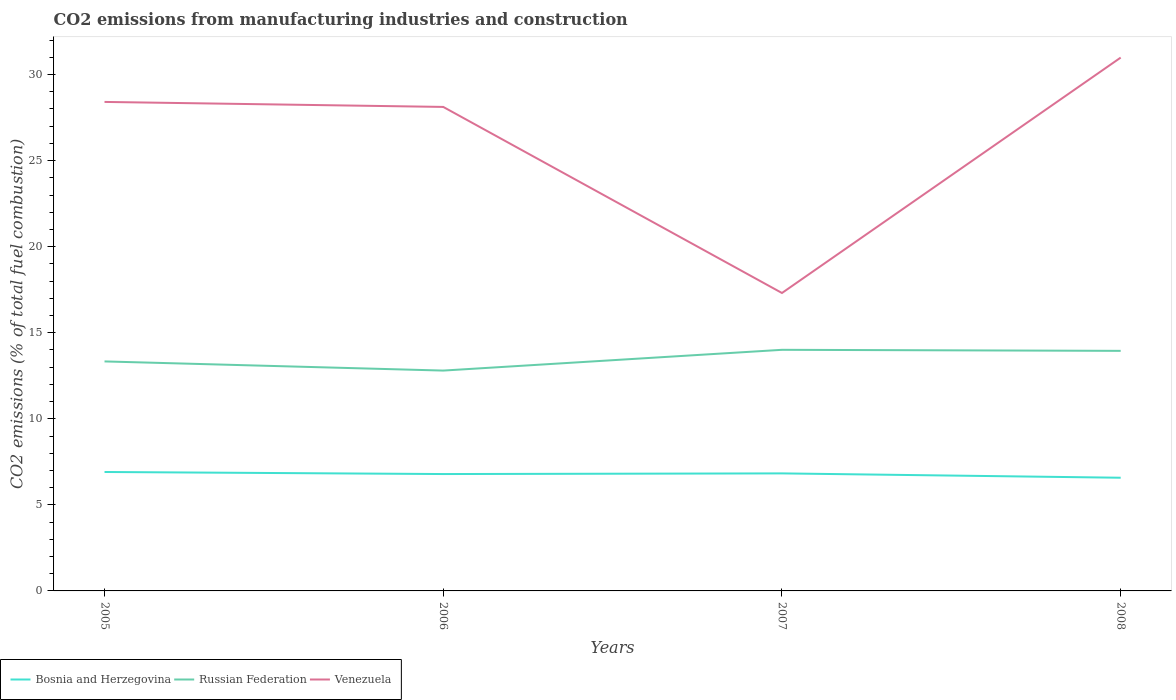How many different coloured lines are there?
Provide a short and direct response. 3. Does the line corresponding to Bosnia and Herzegovina intersect with the line corresponding to Russian Federation?
Offer a very short reply. No. Across all years, what is the maximum amount of CO2 emitted in Venezuela?
Ensure brevity in your answer.  17.31. In which year was the amount of CO2 emitted in Bosnia and Herzegovina maximum?
Offer a terse response. 2008. What is the total amount of CO2 emitted in Bosnia and Herzegovina in the graph?
Offer a very short reply. 0.33. What is the difference between the highest and the second highest amount of CO2 emitted in Venezuela?
Offer a very short reply. 13.68. Is the amount of CO2 emitted in Venezuela strictly greater than the amount of CO2 emitted in Bosnia and Herzegovina over the years?
Keep it short and to the point. No. How many lines are there?
Keep it short and to the point. 3. Does the graph contain any zero values?
Keep it short and to the point. No. How are the legend labels stacked?
Your response must be concise. Horizontal. What is the title of the graph?
Give a very brief answer. CO2 emissions from manufacturing industries and construction. Does "Liberia" appear as one of the legend labels in the graph?
Your answer should be compact. No. What is the label or title of the X-axis?
Ensure brevity in your answer.  Years. What is the label or title of the Y-axis?
Make the answer very short. CO2 emissions (% of total fuel combustion). What is the CO2 emissions (% of total fuel combustion) in Bosnia and Herzegovina in 2005?
Offer a very short reply. 6.91. What is the CO2 emissions (% of total fuel combustion) of Russian Federation in 2005?
Your response must be concise. 13.33. What is the CO2 emissions (% of total fuel combustion) of Venezuela in 2005?
Offer a terse response. 28.41. What is the CO2 emissions (% of total fuel combustion) in Bosnia and Herzegovina in 2006?
Make the answer very short. 6.79. What is the CO2 emissions (% of total fuel combustion) of Russian Federation in 2006?
Keep it short and to the point. 12.8. What is the CO2 emissions (% of total fuel combustion) of Venezuela in 2006?
Give a very brief answer. 28.12. What is the CO2 emissions (% of total fuel combustion) of Bosnia and Herzegovina in 2007?
Make the answer very short. 6.83. What is the CO2 emissions (% of total fuel combustion) in Russian Federation in 2007?
Keep it short and to the point. 14.01. What is the CO2 emissions (% of total fuel combustion) of Venezuela in 2007?
Your answer should be compact. 17.31. What is the CO2 emissions (% of total fuel combustion) of Bosnia and Herzegovina in 2008?
Keep it short and to the point. 6.58. What is the CO2 emissions (% of total fuel combustion) of Russian Federation in 2008?
Give a very brief answer. 13.95. What is the CO2 emissions (% of total fuel combustion) in Venezuela in 2008?
Provide a short and direct response. 30.99. Across all years, what is the maximum CO2 emissions (% of total fuel combustion) of Bosnia and Herzegovina?
Ensure brevity in your answer.  6.91. Across all years, what is the maximum CO2 emissions (% of total fuel combustion) in Russian Federation?
Ensure brevity in your answer.  14.01. Across all years, what is the maximum CO2 emissions (% of total fuel combustion) of Venezuela?
Make the answer very short. 30.99. Across all years, what is the minimum CO2 emissions (% of total fuel combustion) in Bosnia and Herzegovina?
Keep it short and to the point. 6.58. Across all years, what is the minimum CO2 emissions (% of total fuel combustion) of Russian Federation?
Keep it short and to the point. 12.8. Across all years, what is the minimum CO2 emissions (% of total fuel combustion) of Venezuela?
Offer a terse response. 17.31. What is the total CO2 emissions (% of total fuel combustion) in Bosnia and Herzegovina in the graph?
Give a very brief answer. 27.1. What is the total CO2 emissions (% of total fuel combustion) of Russian Federation in the graph?
Provide a succinct answer. 54.09. What is the total CO2 emissions (% of total fuel combustion) in Venezuela in the graph?
Offer a very short reply. 104.83. What is the difference between the CO2 emissions (% of total fuel combustion) of Bosnia and Herzegovina in 2005 and that in 2006?
Offer a very short reply. 0.12. What is the difference between the CO2 emissions (% of total fuel combustion) of Russian Federation in 2005 and that in 2006?
Make the answer very short. 0.53. What is the difference between the CO2 emissions (% of total fuel combustion) of Venezuela in 2005 and that in 2006?
Provide a short and direct response. 0.29. What is the difference between the CO2 emissions (% of total fuel combustion) in Bosnia and Herzegovina in 2005 and that in 2007?
Your response must be concise. 0.08. What is the difference between the CO2 emissions (% of total fuel combustion) in Russian Federation in 2005 and that in 2007?
Make the answer very short. -0.67. What is the difference between the CO2 emissions (% of total fuel combustion) of Venezuela in 2005 and that in 2007?
Offer a terse response. 11.1. What is the difference between the CO2 emissions (% of total fuel combustion) of Bosnia and Herzegovina in 2005 and that in 2008?
Provide a short and direct response. 0.33. What is the difference between the CO2 emissions (% of total fuel combustion) in Russian Federation in 2005 and that in 2008?
Your answer should be very brief. -0.61. What is the difference between the CO2 emissions (% of total fuel combustion) in Venezuela in 2005 and that in 2008?
Your answer should be compact. -2.58. What is the difference between the CO2 emissions (% of total fuel combustion) of Bosnia and Herzegovina in 2006 and that in 2007?
Your response must be concise. -0.04. What is the difference between the CO2 emissions (% of total fuel combustion) of Russian Federation in 2006 and that in 2007?
Your answer should be very brief. -1.21. What is the difference between the CO2 emissions (% of total fuel combustion) in Venezuela in 2006 and that in 2007?
Give a very brief answer. 10.81. What is the difference between the CO2 emissions (% of total fuel combustion) of Bosnia and Herzegovina in 2006 and that in 2008?
Keep it short and to the point. 0.21. What is the difference between the CO2 emissions (% of total fuel combustion) in Russian Federation in 2006 and that in 2008?
Make the answer very short. -1.15. What is the difference between the CO2 emissions (% of total fuel combustion) of Venezuela in 2006 and that in 2008?
Your answer should be compact. -2.87. What is the difference between the CO2 emissions (% of total fuel combustion) of Bosnia and Herzegovina in 2007 and that in 2008?
Provide a succinct answer. 0.25. What is the difference between the CO2 emissions (% of total fuel combustion) in Russian Federation in 2007 and that in 2008?
Give a very brief answer. 0.06. What is the difference between the CO2 emissions (% of total fuel combustion) in Venezuela in 2007 and that in 2008?
Your answer should be very brief. -13.68. What is the difference between the CO2 emissions (% of total fuel combustion) in Bosnia and Herzegovina in 2005 and the CO2 emissions (% of total fuel combustion) in Russian Federation in 2006?
Your response must be concise. -5.89. What is the difference between the CO2 emissions (% of total fuel combustion) in Bosnia and Herzegovina in 2005 and the CO2 emissions (% of total fuel combustion) in Venezuela in 2006?
Offer a terse response. -21.21. What is the difference between the CO2 emissions (% of total fuel combustion) of Russian Federation in 2005 and the CO2 emissions (% of total fuel combustion) of Venezuela in 2006?
Your response must be concise. -14.79. What is the difference between the CO2 emissions (% of total fuel combustion) in Bosnia and Herzegovina in 2005 and the CO2 emissions (% of total fuel combustion) in Russian Federation in 2007?
Offer a very short reply. -7.1. What is the difference between the CO2 emissions (% of total fuel combustion) of Bosnia and Herzegovina in 2005 and the CO2 emissions (% of total fuel combustion) of Venezuela in 2007?
Make the answer very short. -10.4. What is the difference between the CO2 emissions (% of total fuel combustion) of Russian Federation in 2005 and the CO2 emissions (% of total fuel combustion) of Venezuela in 2007?
Your answer should be compact. -3.98. What is the difference between the CO2 emissions (% of total fuel combustion) in Bosnia and Herzegovina in 2005 and the CO2 emissions (% of total fuel combustion) in Russian Federation in 2008?
Give a very brief answer. -7.04. What is the difference between the CO2 emissions (% of total fuel combustion) in Bosnia and Herzegovina in 2005 and the CO2 emissions (% of total fuel combustion) in Venezuela in 2008?
Offer a very short reply. -24.08. What is the difference between the CO2 emissions (% of total fuel combustion) in Russian Federation in 2005 and the CO2 emissions (% of total fuel combustion) in Venezuela in 2008?
Provide a short and direct response. -17.65. What is the difference between the CO2 emissions (% of total fuel combustion) in Bosnia and Herzegovina in 2006 and the CO2 emissions (% of total fuel combustion) in Russian Federation in 2007?
Your response must be concise. -7.22. What is the difference between the CO2 emissions (% of total fuel combustion) of Bosnia and Herzegovina in 2006 and the CO2 emissions (% of total fuel combustion) of Venezuela in 2007?
Keep it short and to the point. -10.52. What is the difference between the CO2 emissions (% of total fuel combustion) in Russian Federation in 2006 and the CO2 emissions (% of total fuel combustion) in Venezuela in 2007?
Your answer should be compact. -4.51. What is the difference between the CO2 emissions (% of total fuel combustion) of Bosnia and Herzegovina in 2006 and the CO2 emissions (% of total fuel combustion) of Russian Federation in 2008?
Ensure brevity in your answer.  -7.16. What is the difference between the CO2 emissions (% of total fuel combustion) in Bosnia and Herzegovina in 2006 and the CO2 emissions (% of total fuel combustion) in Venezuela in 2008?
Make the answer very short. -24.2. What is the difference between the CO2 emissions (% of total fuel combustion) in Russian Federation in 2006 and the CO2 emissions (% of total fuel combustion) in Venezuela in 2008?
Your response must be concise. -18.18. What is the difference between the CO2 emissions (% of total fuel combustion) of Bosnia and Herzegovina in 2007 and the CO2 emissions (% of total fuel combustion) of Russian Federation in 2008?
Provide a succinct answer. -7.12. What is the difference between the CO2 emissions (% of total fuel combustion) in Bosnia and Herzegovina in 2007 and the CO2 emissions (% of total fuel combustion) in Venezuela in 2008?
Your answer should be compact. -24.16. What is the difference between the CO2 emissions (% of total fuel combustion) of Russian Federation in 2007 and the CO2 emissions (% of total fuel combustion) of Venezuela in 2008?
Your answer should be very brief. -16.98. What is the average CO2 emissions (% of total fuel combustion) in Bosnia and Herzegovina per year?
Provide a short and direct response. 6.78. What is the average CO2 emissions (% of total fuel combustion) in Russian Federation per year?
Keep it short and to the point. 13.52. What is the average CO2 emissions (% of total fuel combustion) of Venezuela per year?
Provide a succinct answer. 26.21. In the year 2005, what is the difference between the CO2 emissions (% of total fuel combustion) of Bosnia and Herzegovina and CO2 emissions (% of total fuel combustion) of Russian Federation?
Provide a short and direct response. -6.42. In the year 2005, what is the difference between the CO2 emissions (% of total fuel combustion) in Bosnia and Herzegovina and CO2 emissions (% of total fuel combustion) in Venezuela?
Your response must be concise. -21.5. In the year 2005, what is the difference between the CO2 emissions (% of total fuel combustion) in Russian Federation and CO2 emissions (% of total fuel combustion) in Venezuela?
Offer a terse response. -15.08. In the year 2006, what is the difference between the CO2 emissions (% of total fuel combustion) in Bosnia and Herzegovina and CO2 emissions (% of total fuel combustion) in Russian Federation?
Offer a very short reply. -6.01. In the year 2006, what is the difference between the CO2 emissions (% of total fuel combustion) of Bosnia and Herzegovina and CO2 emissions (% of total fuel combustion) of Venezuela?
Offer a terse response. -21.33. In the year 2006, what is the difference between the CO2 emissions (% of total fuel combustion) of Russian Federation and CO2 emissions (% of total fuel combustion) of Venezuela?
Make the answer very short. -15.32. In the year 2007, what is the difference between the CO2 emissions (% of total fuel combustion) in Bosnia and Herzegovina and CO2 emissions (% of total fuel combustion) in Russian Federation?
Your answer should be compact. -7.18. In the year 2007, what is the difference between the CO2 emissions (% of total fuel combustion) of Bosnia and Herzegovina and CO2 emissions (% of total fuel combustion) of Venezuela?
Your answer should be compact. -10.48. In the year 2007, what is the difference between the CO2 emissions (% of total fuel combustion) in Russian Federation and CO2 emissions (% of total fuel combustion) in Venezuela?
Your answer should be compact. -3.3. In the year 2008, what is the difference between the CO2 emissions (% of total fuel combustion) of Bosnia and Herzegovina and CO2 emissions (% of total fuel combustion) of Russian Federation?
Keep it short and to the point. -7.37. In the year 2008, what is the difference between the CO2 emissions (% of total fuel combustion) in Bosnia and Herzegovina and CO2 emissions (% of total fuel combustion) in Venezuela?
Offer a very short reply. -24.41. In the year 2008, what is the difference between the CO2 emissions (% of total fuel combustion) in Russian Federation and CO2 emissions (% of total fuel combustion) in Venezuela?
Your response must be concise. -17.04. What is the ratio of the CO2 emissions (% of total fuel combustion) in Bosnia and Herzegovina in 2005 to that in 2006?
Give a very brief answer. 1.02. What is the ratio of the CO2 emissions (% of total fuel combustion) of Russian Federation in 2005 to that in 2006?
Provide a succinct answer. 1.04. What is the ratio of the CO2 emissions (% of total fuel combustion) in Venezuela in 2005 to that in 2006?
Keep it short and to the point. 1.01. What is the ratio of the CO2 emissions (% of total fuel combustion) of Bosnia and Herzegovina in 2005 to that in 2007?
Keep it short and to the point. 1.01. What is the ratio of the CO2 emissions (% of total fuel combustion) in Russian Federation in 2005 to that in 2007?
Offer a terse response. 0.95. What is the ratio of the CO2 emissions (% of total fuel combustion) in Venezuela in 2005 to that in 2007?
Make the answer very short. 1.64. What is the ratio of the CO2 emissions (% of total fuel combustion) in Bosnia and Herzegovina in 2005 to that in 2008?
Offer a terse response. 1.05. What is the ratio of the CO2 emissions (% of total fuel combustion) of Russian Federation in 2005 to that in 2008?
Your response must be concise. 0.96. What is the ratio of the CO2 emissions (% of total fuel combustion) in Venezuela in 2005 to that in 2008?
Give a very brief answer. 0.92. What is the ratio of the CO2 emissions (% of total fuel combustion) of Russian Federation in 2006 to that in 2007?
Ensure brevity in your answer.  0.91. What is the ratio of the CO2 emissions (% of total fuel combustion) in Venezuela in 2006 to that in 2007?
Offer a very short reply. 1.62. What is the ratio of the CO2 emissions (% of total fuel combustion) of Bosnia and Herzegovina in 2006 to that in 2008?
Offer a very short reply. 1.03. What is the ratio of the CO2 emissions (% of total fuel combustion) of Russian Federation in 2006 to that in 2008?
Keep it short and to the point. 0.92. What is the ratio of the CO2 emissions (% of total fuel combustion) of Venezuela in 2006 to that in 2008?
Your answer should be compact. 0.91. What is the ratio of the CO2 emissions (% of total fuel combustion) in Bosnia and Herzegovina in 2007 to that in 2008?
Keep it short and to the point. 1.04. What is the ratio of the CO2 emissions (% of total fuel combustion) of Russian Federation in 2007 to that in 2008?
Give a very brief answer. 1. What is the ratio of the CO2 emissions (% of total fuel combustion) of Venezuela in 2007 to that in 2008?
Offer a terse response. 0.56. What is the difference between the highest and the second highest CO2 emissions (% of total fuel combustion) in Bosnia and Herzegovina?
Provide a short and direct response. 0.08. What is the difference between the highest and the second highest CO2 emissions (% of total fuel combustion) of Russian Federation?
Provide a short and direct response. 0.06. What is the difference between the highest and the second highest CO2 emissions (% of total fuel combustion) of Venezuela?
Ensure brevity in your answer.  2.58. What is the difference between the highest and the lowest CO2 emissions (% of total fuel combustion) in Bosnia and Herzegovina?
Provide a short and direct response. 0.33. What is the difference between the highest and the lowest CO2 emissions (% of total fuel combustion) in Russian Federation?
Keep it short and to the point. 1.21. What is the difference between the highest and the lowest CO2 emissions (% of total fuel combustion) in Venezuela?
Provide a short and direct response. 13.68. 